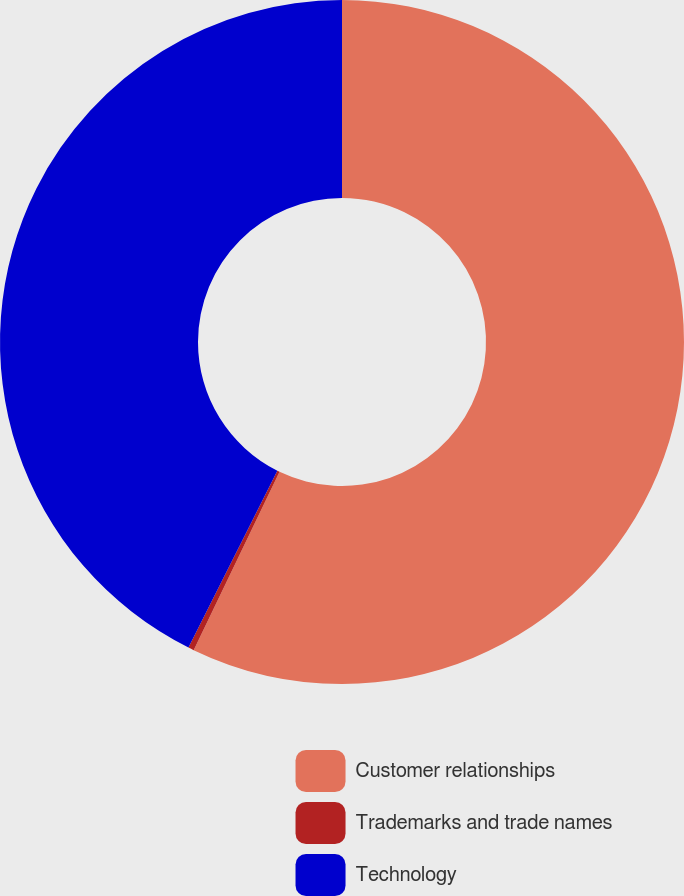Convert chart to OTSL. <chart><loc_0><loc_0><loc_500><loc_500><pie_chart><fcel>Customer relationships<fcel>Trademarks and trade names<fcel>Technology<nl><fcel>57.14%<fcel>0.27%<fcel>42.59%<nl></chart> 